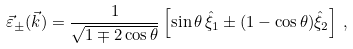Convert formula to latex. <formula><loc_0><loc_0><loc_500><loc_500>\vec { \varepsilon } _ { \pm } ( \vec { k } ) = \frac { 1 } { \sqrt { 1 \mp 2 \cos \theta } } \left [ \sin \theta \, \hat { \xi } _ { 1 } \pm ( 1 - \cos \theta ) \hat { \xi } _ { 2 } \right ] \, ,</formula> 